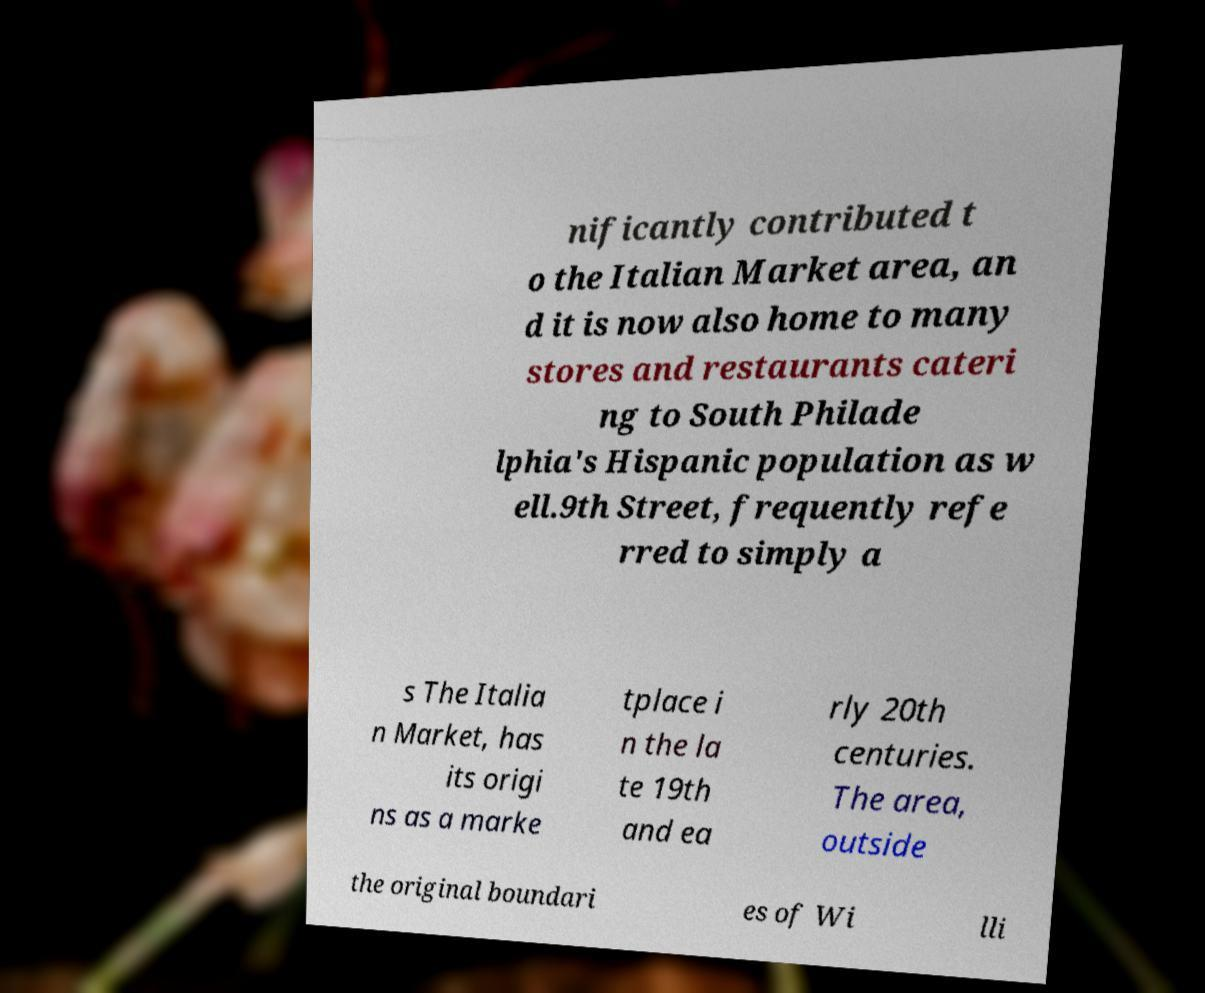Could you extract and type out the text from this image? nificantly contributed t o the Italian Market area, an d it is now also home to many stores and restaurants cateri ng to South Philade lphia's Hispanic population as w ell.9th Street, frequently refe rred to simply a s The Italia n Market, has its origi ns as a marke tplace i n the la te 19th and ea rly 20th centuries. The area, outside the original boundari es of Wi lli 